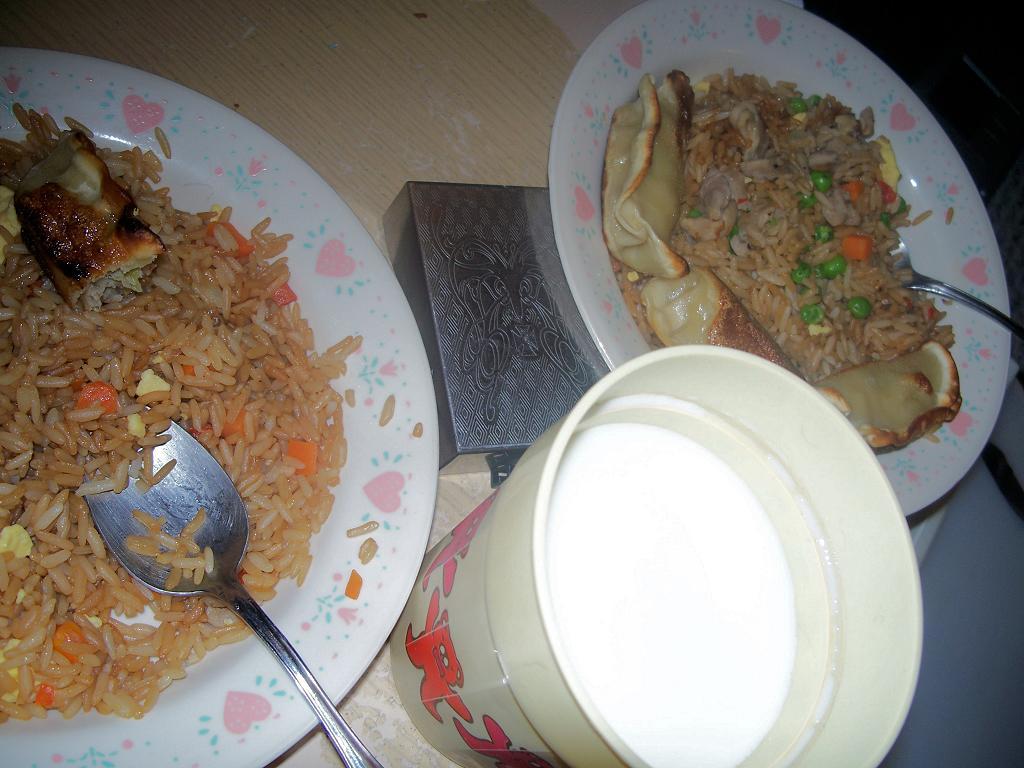Please provide a concise description of this image. Here we can see plates, food, glass and steel box. 